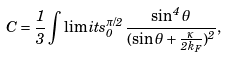Convert formula to latex. <formula><loc_0><loc_0><loc_500><loc_500>C = \frac { 1 } { 3 } \int \lim i t s _ { 0 } ^ { \pi / 2 } \frac { \sin ^ { 4 } { \theta } } { ( \sin { \theta } + \frac { \kappa } { 2 k _ { F } } ) ^ { 2 } } ,</formula> 